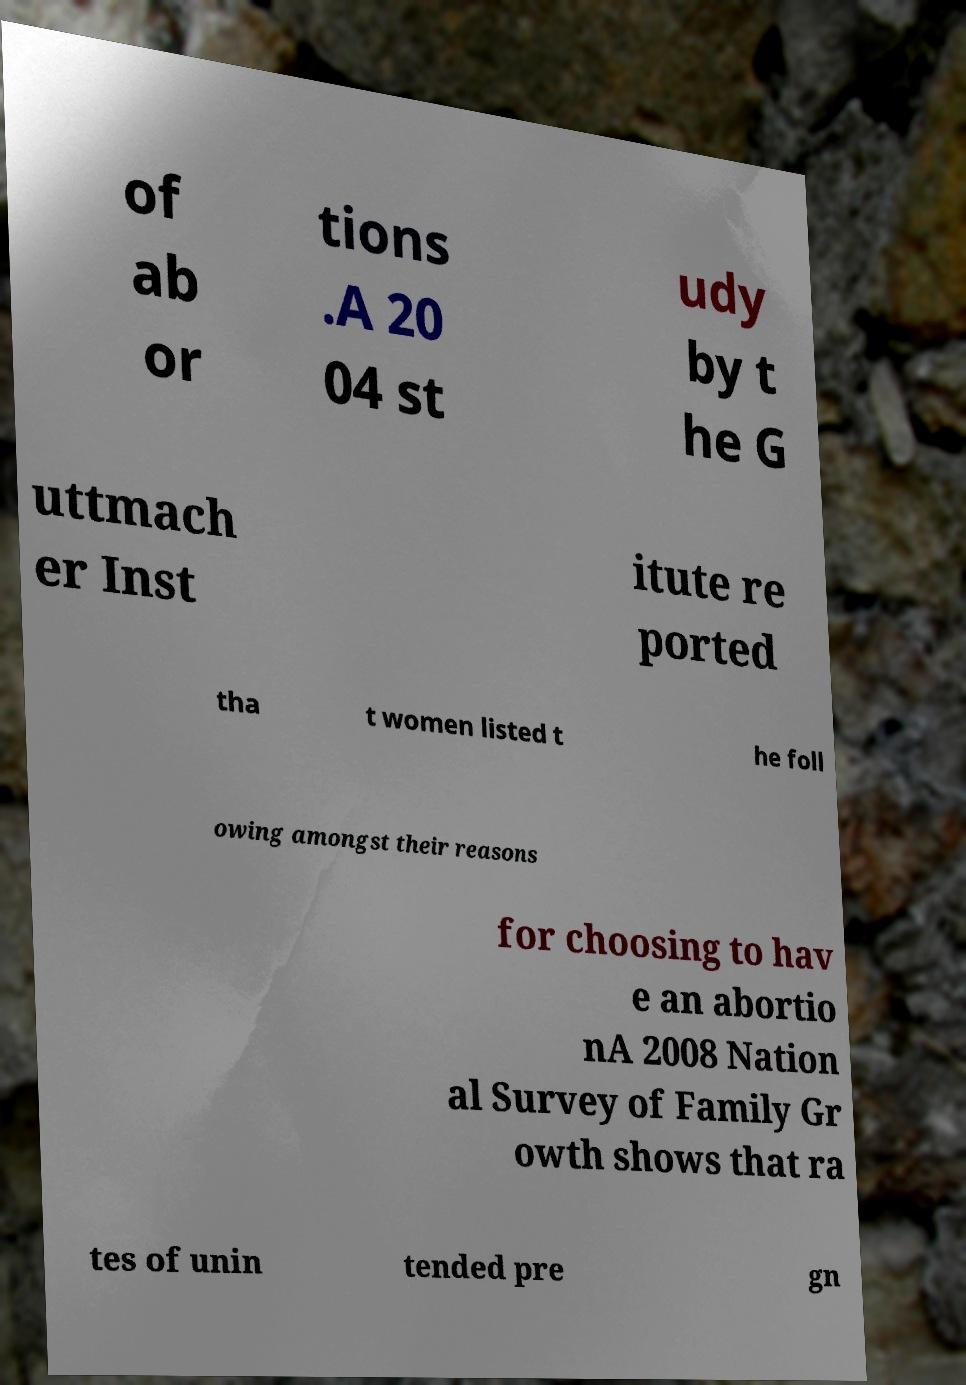Please read and relay the text visible in this image. What does it say? of ab or tions .A 20 04 st udy by t he G uttmach er Inst itute re ported tha t women listed t he foll owing amongst their reasons for choosing to hav e an abortio nA 2008 Nation al Survey of Family Gr owth shows that ra tes of unin tended pre gn 